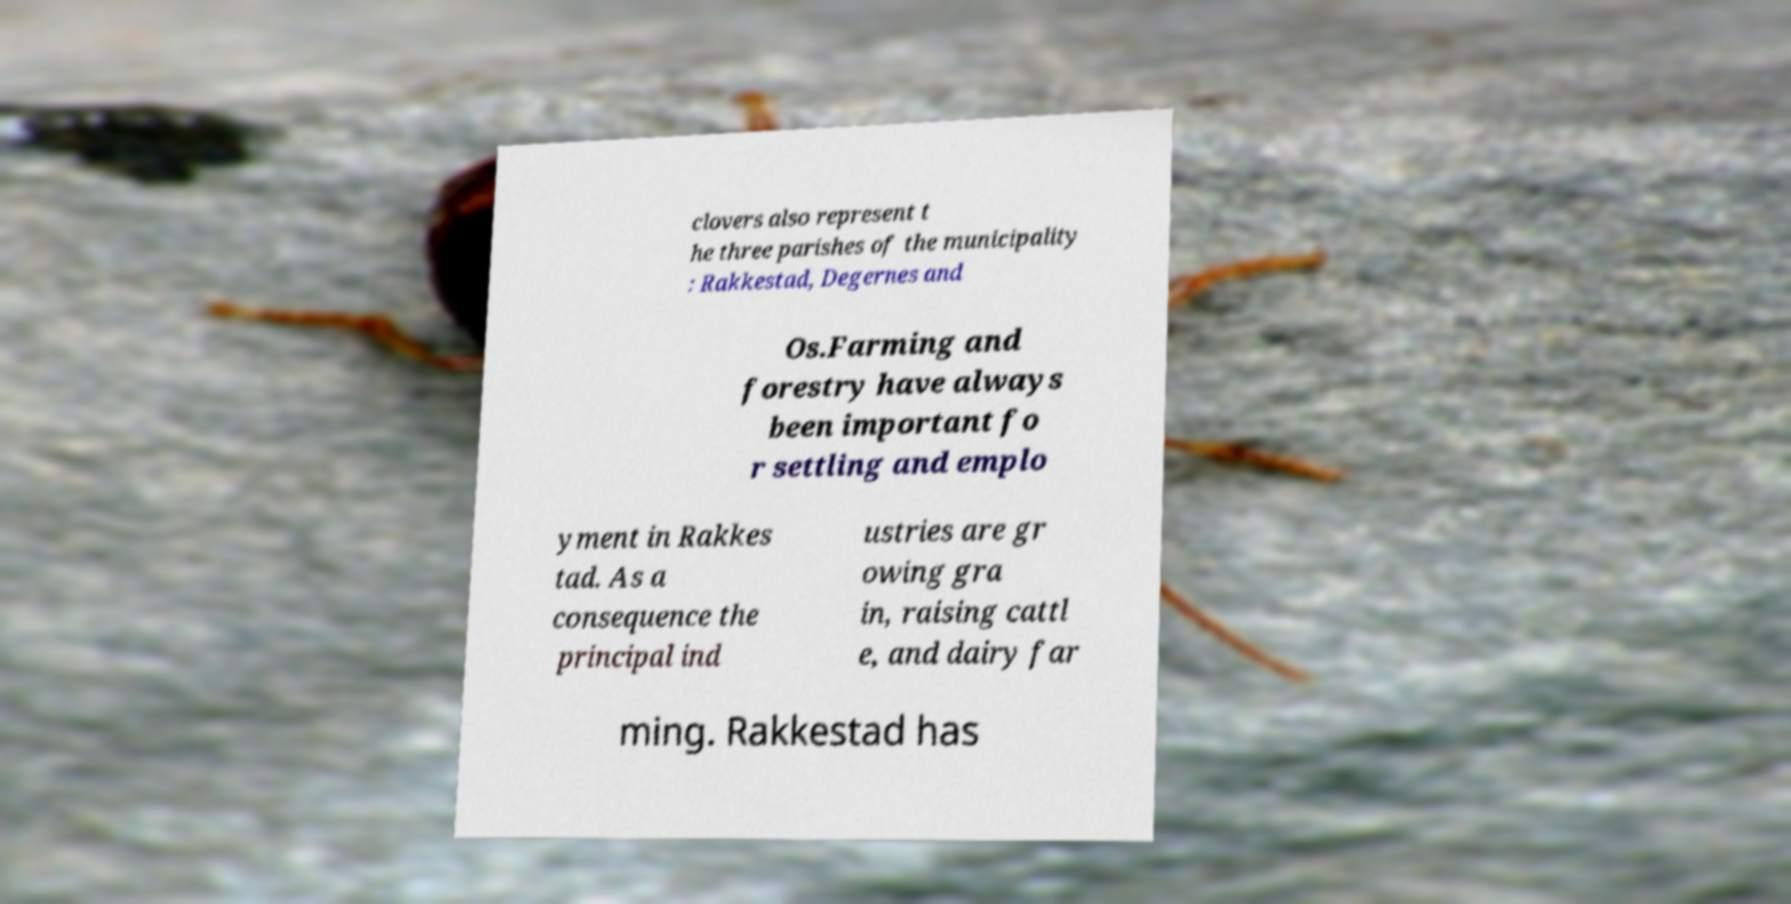Could you assist in decoding the text presented in this image and type it out clearly? clovers also represent t he three parishes of the municipality : Rakkestad, Degernes and Os.Farming and forestry have always been important fo r settling and emplo yment in Rakkes tad. As a consequence the principal ind ustries are gr owing gra in, raising cattl e, and dairy far ming. Rakkestad has 